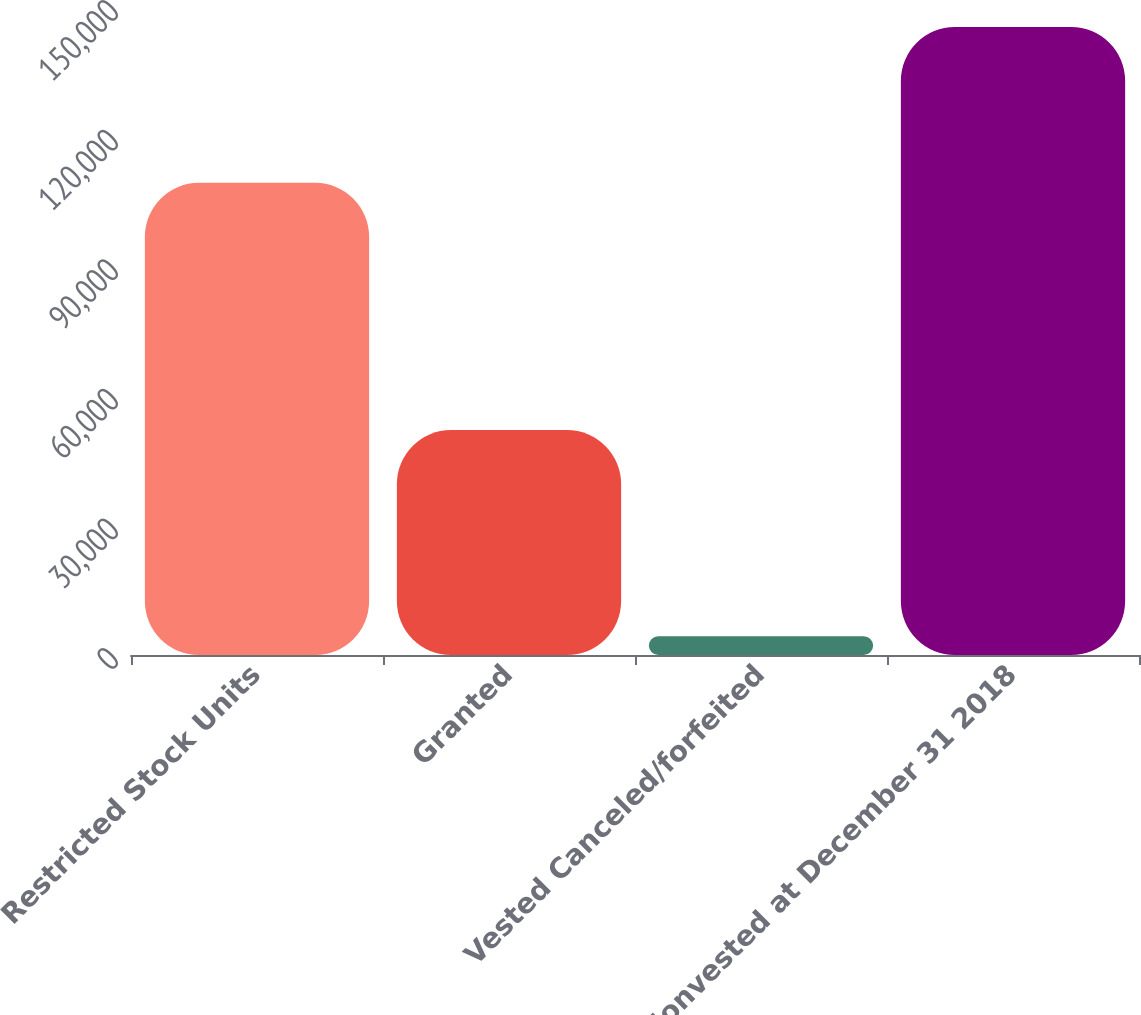Convert chart. <chart><loc_0><loc_0><loc_500><loc_500><bar_chart><fcel>Restricted Stock Units<fcel>Granted<fcel>Vested Canceled/forfeited<fcel>Nonvested at December 31 2018<nl><fcel>109302<fcel>52065<fcel>4366<fcel>145379<nl></chart> 